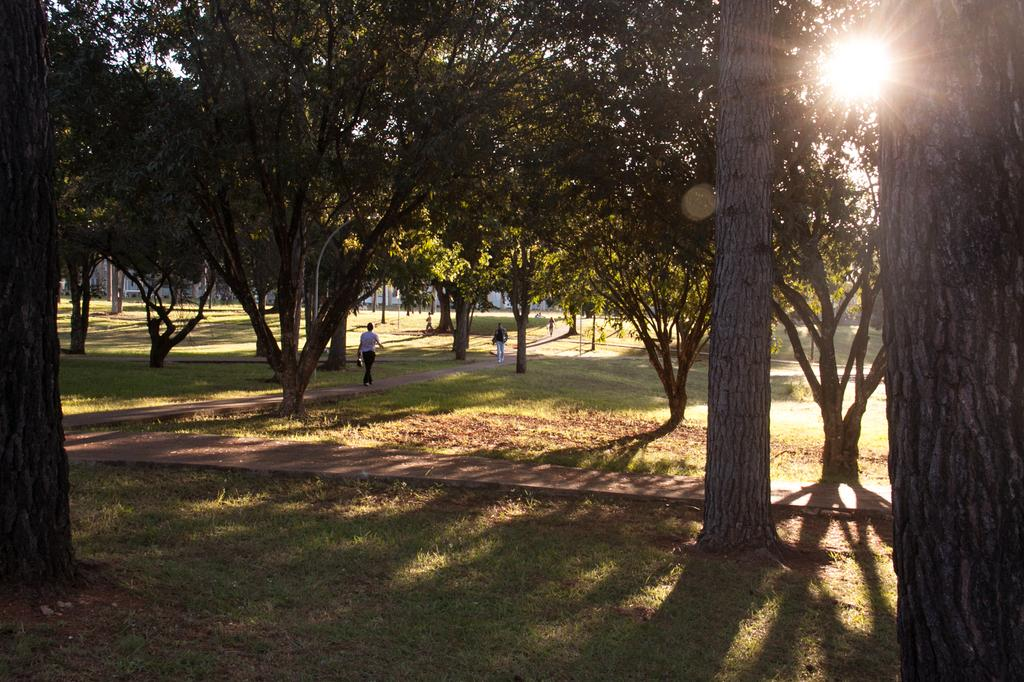How many people are in the image? There are two persons in the image. What are the persons doing in the image? The persons are walking on a pathway. What type of vegetation is present in the image? There are trees in the image. What is the ground surface like in the image? There is grass visible in the image. What types of toys can be seen scattered on the grass in the image? There are no toys present in the image; it features include two people walking on a pathway, trees, and grass. 